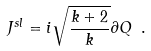Convert formula to latex. <formula><loc_0><loc_0><loc_500><loc_500>J ^ { s l } = i \sqrt { \frac { k + 2 } { k } } \partial Q \ .</formula> 